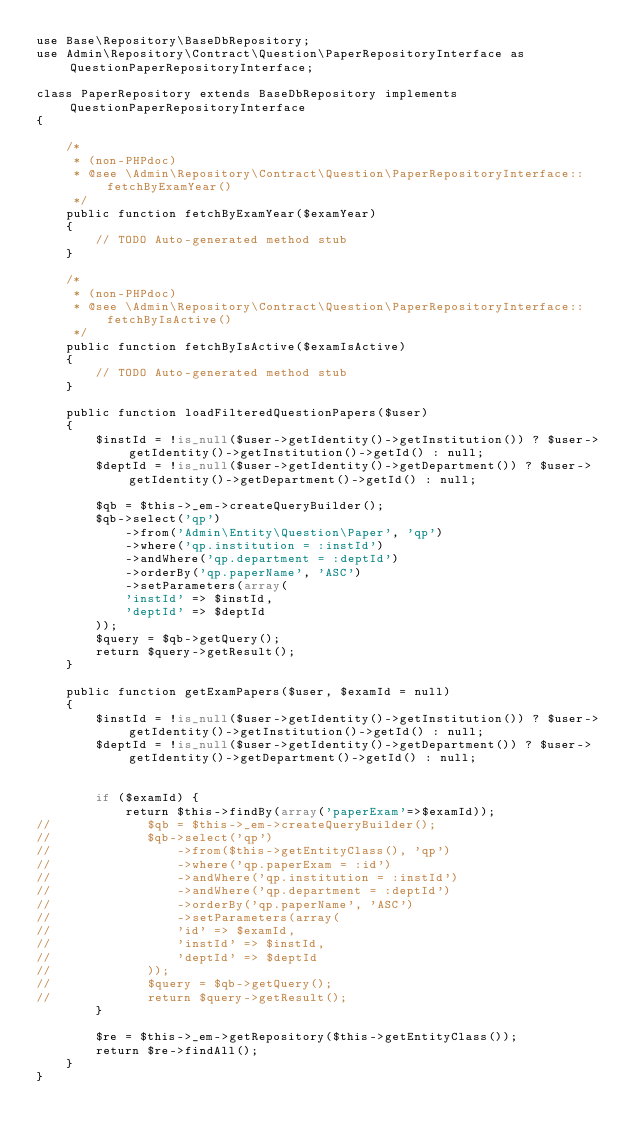<code> <loc_0><loc_0><loc_500><loc_500><_PHP_>use Base\Repository\BaseDbRepository;
use Admin\Repository\Contract\Question\PaperRepositoryInterface as QuestionPaperRepositoryInterface;

class PaperRepository extends BaseDbRepository implements QuestionPaperRepositoryInterface
{

    /*
     * (non-PHPdoc)
     * @see \Admin\Repository\Contract\Question\PaperRepositoryInterface::fetchByExamYear()
     */
    public function fetchByExamYear($examYear)
    {
        // TODO Auto-generated method stub
    }

    /*
     * (non-PHPdoc)
     * @see \Admin\Repository\Contract\Question\PaperRepositoryInterface::fetchByIsActive()
     */
    public function fetchByIsActive($examIsActive)
    {
        // TODO Auto-generated method stub
    }

    public function loadFilteredQuestionPapers($user)
    {
        $instId = !is_null($user->getIdentity()->getInstitution()) ? $user->getIdentity()->getInstitution()->getId() : null;
        $deptId = !is_null($user->getIdentity()->getDepartment()) ? $user->getIdentity()->getDepartment()->getId() : null;
        
        $qb = $this->_em->createQueryBuilder();
        $qb->select('qp')
            ->from('Admin\Entity\Question\Paper', 'qp')
            ->where('qp.institution = :instId')
            ->andWhere('qp.department = :deptId')
            ->orderBy('qp.paperName', 'ASC')
            ->setParameters(array(
            'instId' => $instId,
            'deptId' => $deptId
        ));
        $query = $qb->getQuery();
        return $query->getResult();
    }

    public function getExamPapers($user, $examId = null)
    {
        $instId = !is_null($user->getIdentity()->getInstitution()) ? $user->getIdentity()->getInstitution()->getId() : null;
        $deptId = !is_null($user->getIdentity()->getDepartment()) ? $user->getIdentity()->getDepartment()->getId() : null;
        
        
        if ($examId) {
            return $this->findBy(array('paperExam'=>$examId));
//             $qb = $this->_em->createQueryBuilder();
//             $qb->select('qp')
//                 ->from($this->getEntityClass(), 'qp')
//                 ->where('qp.paperExam = :id')
//                 ->andWhere('qp.institution = :instId')
//                 ->andWhere('qp.department = :deptId')
//                 ->orderBy('qp.paperName', 'ASC')
//                 ->setParameters(array(
//                 'id' => $examId,
//                 'instId' => $instId,
//                 'deptId' => $deptId
//             ));
//             $query = $qb->getQuery();
//             return $query->getResult();
        }
        
        $re = $this->_em->getRepository($this->getEntityClass());
        return $re->findAll();
    }
}</code> 